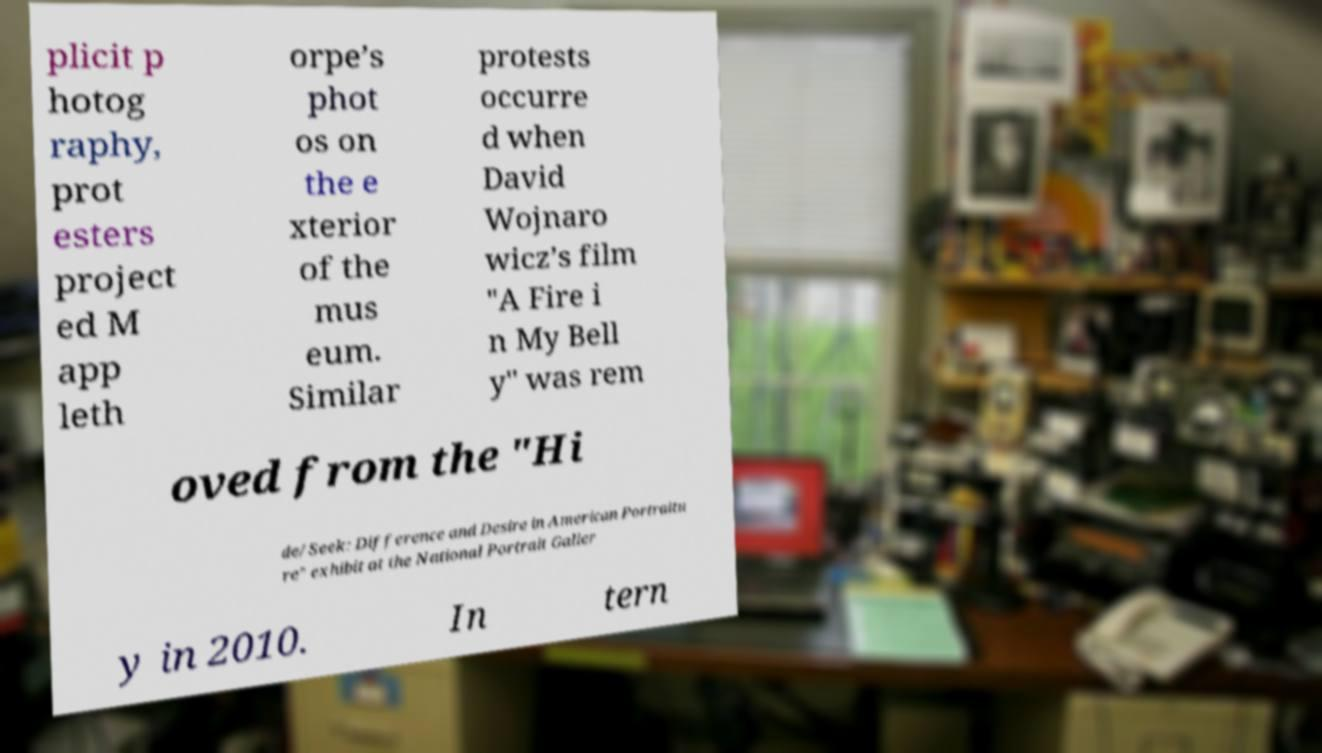What messages or text are displayed in this image? I need them in a readable, typed format. plicit p hotog raphy, prot esters project ed M app leth orpe’s phot os on the e xterior of the mus eum. Similar protests occurre d when David Wojnaro wicz’s film "A Fire i n My Bell y" was rem oved from the "Hi de/Seek: Difference and Desire in American Portraitu re" exhibit at the National Portrait Galler y in 2010. In tern 